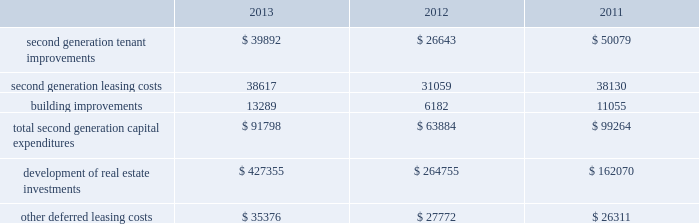36 duke realty corporation annual report 2013 leasing/capital costs tenant improvements and lease-related costs pertaining to our initial leasing of newly completed space , or vacant space in acquired properties , are referred to as first generation expenditures .
Such first generation expenditures for tenant improvements are included within "development of real estate investments" in our consolidated statements of cash flows , while such expenditures for lease-related costs are included within "other deferred leasing costs." cash expenditures related to the construction of a building's shell , as well as the associated site improvements , are also included within "development of real estate investments" in our consolidated statements of cash flows .
Tenant improvements and leasing costs to re-let rental space that we previously leased to tenants are referred to as second generation expenditures .
Building improvements that are not specific to any tenant but serve to improve integral components of our real estate properties are also second generation expenditures .
One of our principal uses of our liquidity is to fund the second generation leasing/capital expenditures of our real estate investments .
The table summarizes our second generation capital expenditures by type of expenditure ( in thousands ) : .
Second generation tenant improvements and leasing costs increased due to a shift in industrial leasing volume from renewal leases to second generation leases ( see data in the key performance indicators section of management's discussion and analysis of financial condition and results of operations ) , which are generally more capital intensive .
Additionally , although the overall renewal volume was lower , renewals for office leases , which are generally more capital intensive than industrial leases , increased from 2012 .
During 2013 , we increased our investment across all product types in non-tenant specific building improvements .
The increase in capital expenditures for the development of real estate investments was the result of our increased focus on wholly owned development projects .
We had wholly owned properties under development with an expected cost of $ 572.6 million at december 31 , 2013 , compared to projects with an expected cost of $ 468.8 million and $ 124.2 million at december 31 , 2012 and 2011 , respectively .
Cash outflows for real estate development investments were $ 427.4 million , $ 264.8 million and $ 162.1 million for december 31 , 2013 , 2012 and 2011 , respectively .
We capitalized $ 31.3 million , $ 30.4 million and $ 25.3 million of overhead costs related to leasing activities , including both first and second generation leases , during the years ended december 31 , 2013 , 2012 and 2011 , respectively .
We capitalized $ 27.1 million , $ 20.0 million and $ 10.4 million of overhead costs related to development activities , including construction , development and tenant improvement projects on first and second generation space , during the years ended december 31 , 2013 , 2012 and 2011 , respectively .
Combined overhead costs capitalized to leasing and development totaled 35.7% ( 35.7 % ) , 31.1% ( 31.1 % ) and 20.6% ( 20.6 % ) of our overall pool of overhead costs at december 31 , 2013 , 2012 and 2011 , respectively .
Further discussion of the capitalization of overhead costs can be found herein , in the discussion of general and administrative expenses in the comparison sections of management's discussion and analysis of financial condition and results of operations. .
What was the average cash outflows for real estate development investments from 2011 to 2013? 
Computations: (((162.1 + (427.4 + 264.8)) + 3) / 2)
Answer: 428.65. 